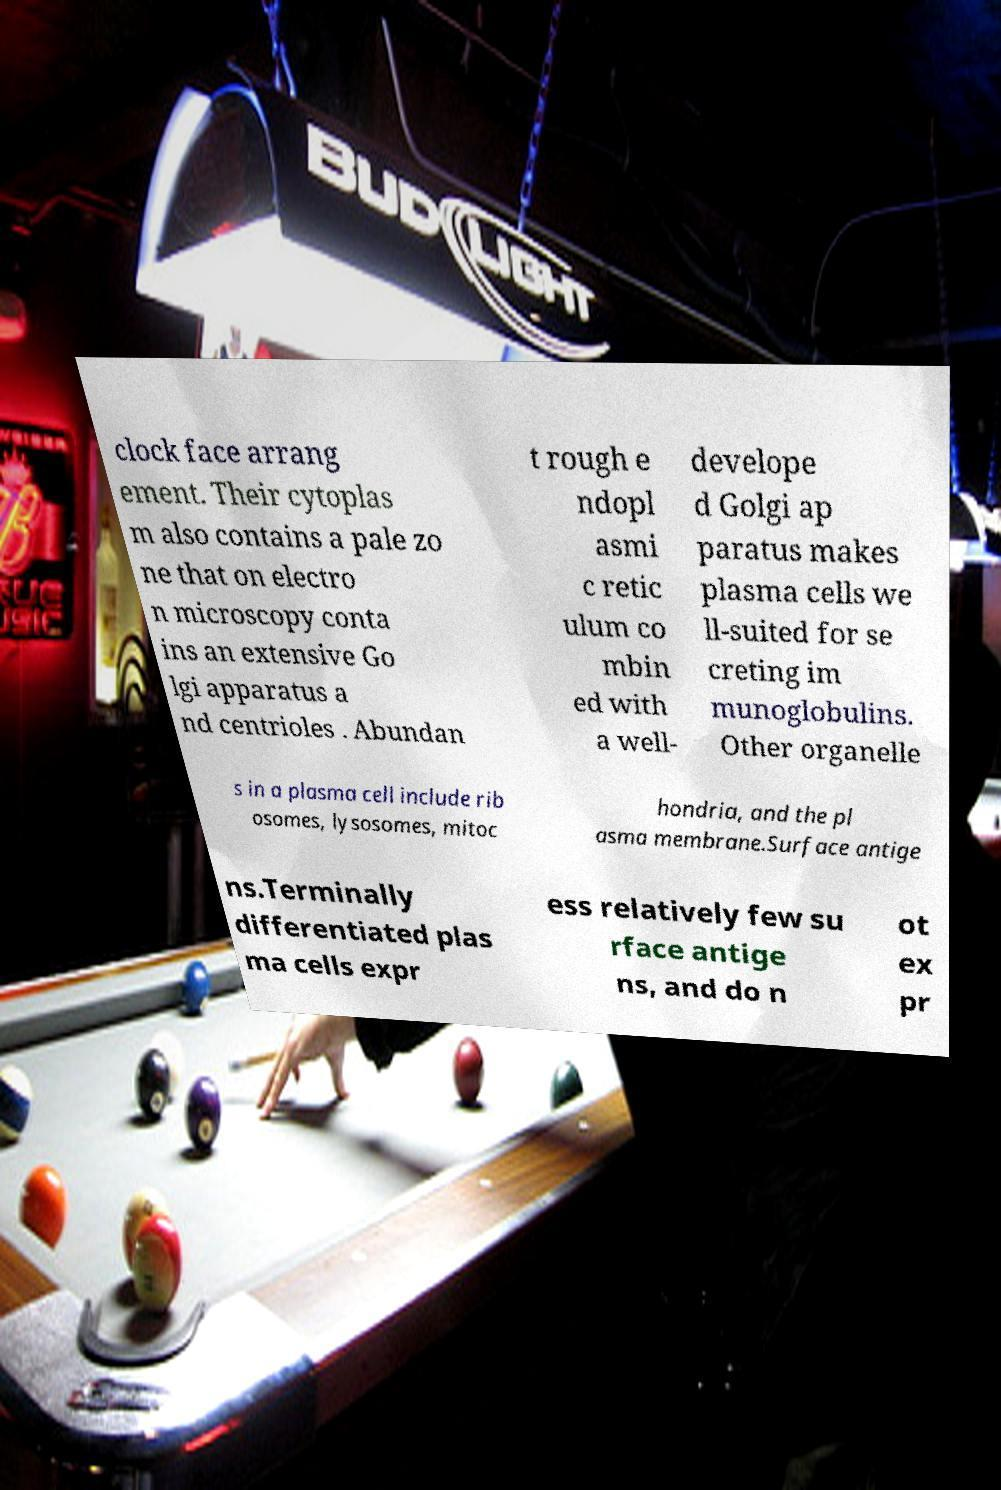I need the written content from this picture converted into text. Can you do that? clock face arrang ement. Their cytoplas m also contains a pale zo ne that on electro n microscopy conta ins an extensive Go lgi apparatus a nd centrioles . Abundan t rough e ndopl asmi c retic ulum co mbin ed with a well- develope d Golgi ap paratus makes plasma cells we ll-suited for se creting im munoglobulins. Other organelle s in a plasma cell include rib osomes, lysosomes, mitoc hondria, and the pl asma membrane.Surface antige ns.Terminally differentiated plas ma cells expr ess relatively few su rface antige ns, and do n ot ex pr 